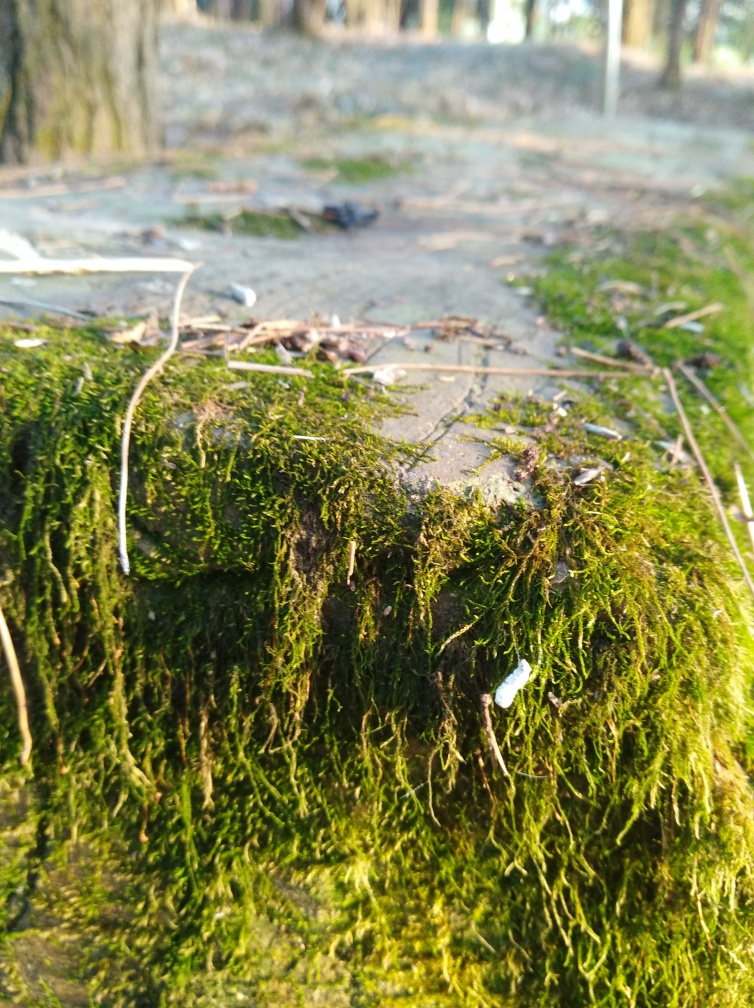What time of day does this photo seem to have been taken? The image looks like it was shot during the late afternoon, as indicated by the warm, golden hue of the sunlight and the long shadows being cast. This can often create a calm and tranquil atmosphere in the scene. 